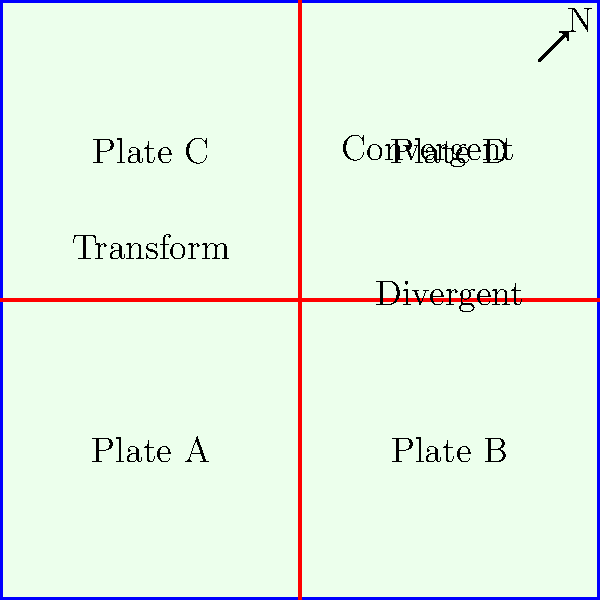Based on the tectonic plate boundary map shown, which type of geological features would you expect to find at the boundary between Plate A and Plate D, and how might this affect regional dating methods? To answer this question, let's analyze the map step-by-step:

1. Identify the boundary: The boundary between Plate A and Plate D is located at the center of the map, where all four plates meet.

2. Determine boundary type: This boundary is characterized by two different types of plate interactions:
   a) A convergent boundary (labeled) between Plates C and D
   b) A transform boundary (labeled) between Plates A and C

3. Geological features at convergent boundaries:
   - Mountain ranges (e.g., the Himalayas, Andes)
   - Subduction zones and deep oceanic trenches
   - Volcanic arcs and increased seismic activity

4. Geological features at transform boundaries:
   - Strike-slip faults (e.g., San Andreas Fault)
   - Offset streams and topographic features
   - Shallow earthquakes

5. Impact on regional dating methods:
   a) Radiometric dating: The presence of volcanic activity at the convergent boundary provides fresh igneous rocks suitable for potassium-argon (K-Ar) or argon-argon (Ar-Ar) dating.
   b) Paleomagnetism: The creation of new crust at the nearby divergent boundary allows for magnetic reversal dating.
   c) Relative dating: The complex interactions at this triple junction create opportunities for cross-cutting relationships and superposition principles to be applied.
   d) Thermochronology: The uplift associated with the convergent boundary makes techniques like fission track dating particularly useful.

6. Regional characteristics:
   The unique combination of convergent and transform boundaries at this location would create a complex geological setting with a mix of volcanic, metamorphic, and sedimentary rocks. This diversity allows for the application of multiple dating techniques, potentially providing a more robust chronology of geological events.
Answer: Complex geological setting with volcanic and fault-related features; multiple dating techniques applicable (radiometric, paleomagnetic, relative, thermochronological) 